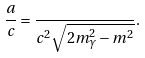<formula> <loc_0><loc_0><loc_500><loc_500>\frac { a } { c } = \frac { } { c ^ { 2 } \sqrt { 2 m _ { \gamma } ^ { 2 } - m ^ { 2 } } } .</formula> 